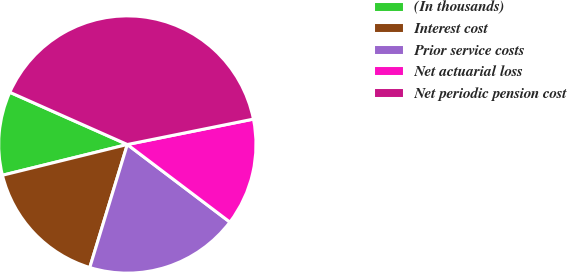<chart> <loc_0><loc_0><loc_500><loc_500><pie_chart><fcel>(In thousands)<fcel>Interest cost<fcel>Prior service costs<fcel>Net actuarial loss<fcel>Net periodic pension cost<nl><fcel>10.5%<fcel>16.44%<fcel>19.41%<fcel>13.47%<fcel>40.18%<nl></chart> 